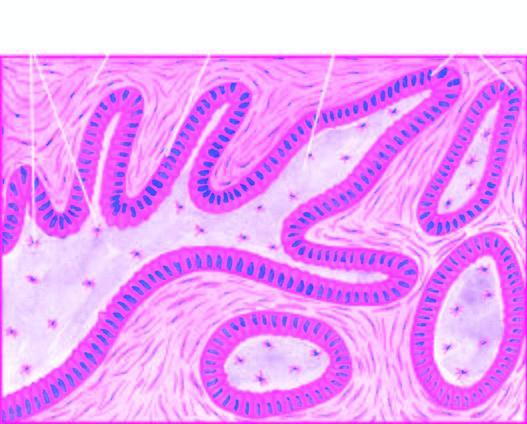what show irregular plexiform masses and network of strands of epithelial cells?
Answer the question using a single word or phrase. Plexiform areas 